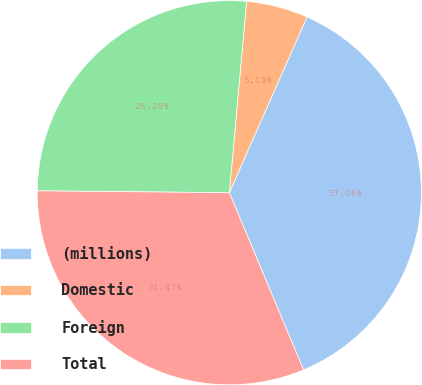<chart> <loc_0><loc_0><loc_500><loc_500><pie_chart><fcel>(millions)<fcel>Domestic<fcel>Foreign<fcel>Total<nl><fcel>37.06%<fcel>5.19%<fcel>26.28%<fcel>31.47%<nl></chart> 